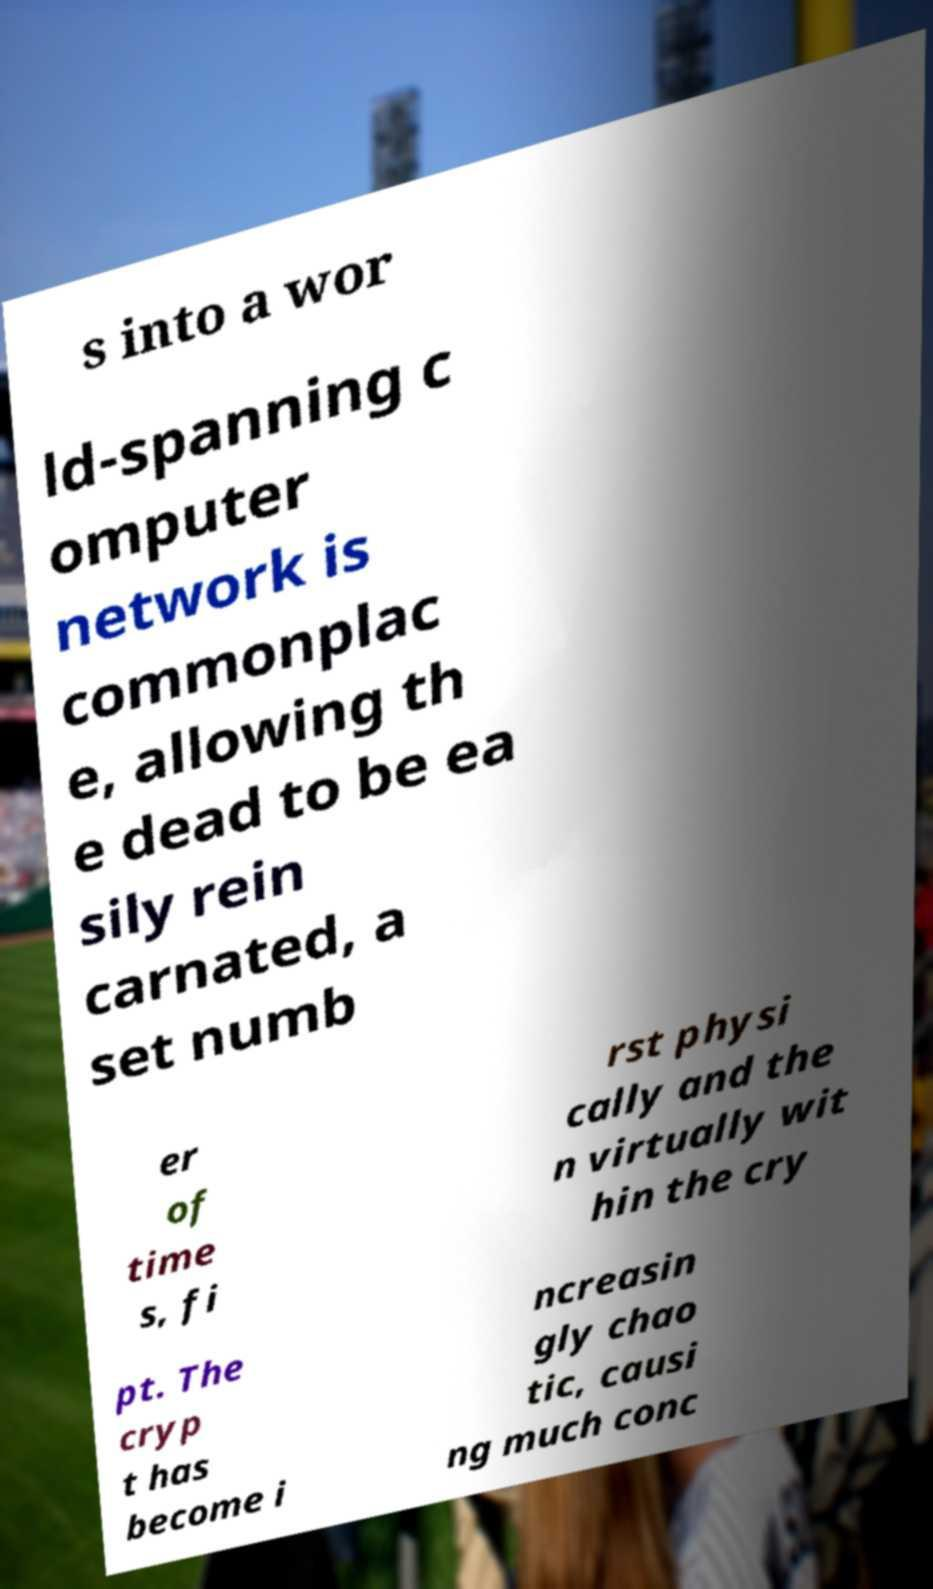Can you read and provide the text displayed in the image?This photo seems to have some interesting text. Can you extract and type it out for me? s into a wor ld-spanning c omputer network is commonplac e, allowing th e dead to be ea sily rein carnated, a set numb er of time s, fi rst physi cally and the n virtually wit hin the cry pt. The cryp t has become i ncreasin gly chao tic, causi ng much conc 